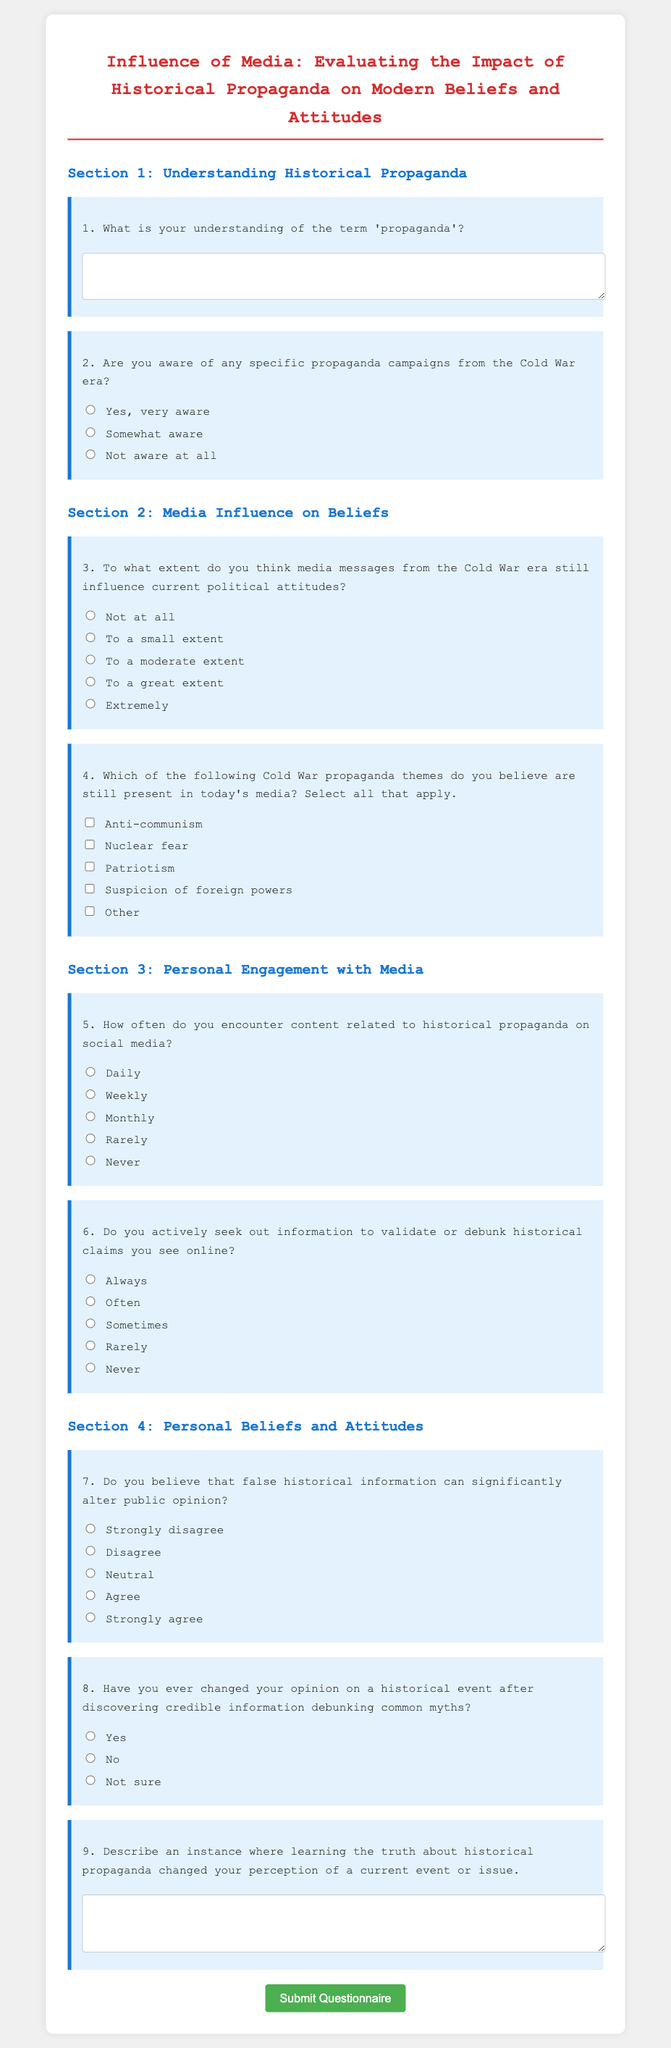What is the title of the questionnaire? The title is the main heading of the document, which describes the subject of the questionnaire.
Answer: Influence of Media: Evaluating the Impact of Historical Propaganda on Modern Beliefs and Attitudes How many sections are in the questionnaire? The document contains four distinct sections, each focusing on different aspects of the topic.
Answer: Four What is the required response format for question 1? The first question requires a description provided in a textarea, indicating a longer answer format.
Answer: Textarea Which propaganda theme is NOT listed as an option in question 4? The listed themes in question 4 help identify contemporary influences from Cold War propaganda; something missing from this list characterizes a gap in options.
Answer: Other How often do respondents encounter content related to historical propaganda? This is a question regarding frequency, and the options range from "Daily" to "Never," indicating various levels of engagement with such content.
Answer: Daily What option indicates a maximum awareness of Cold War propaganda? This question option is about the level of awareness respondents have regarding historical propaganda from the Cold War.
Answer: Yes, very aware Do responders need to provide an answer for question 9? The confirmation of whether responses to specific questions are required shows the importance of participant engagement and personal reflection within the questionnaire.
Answer: Yes What kind of information does question 3 ask for? This question measures beliefs regarding the influence of historical media messages on current political attitudes, which involves a subjective evaluation from the respondents.
Answer: Influence of Cold War media on politics 